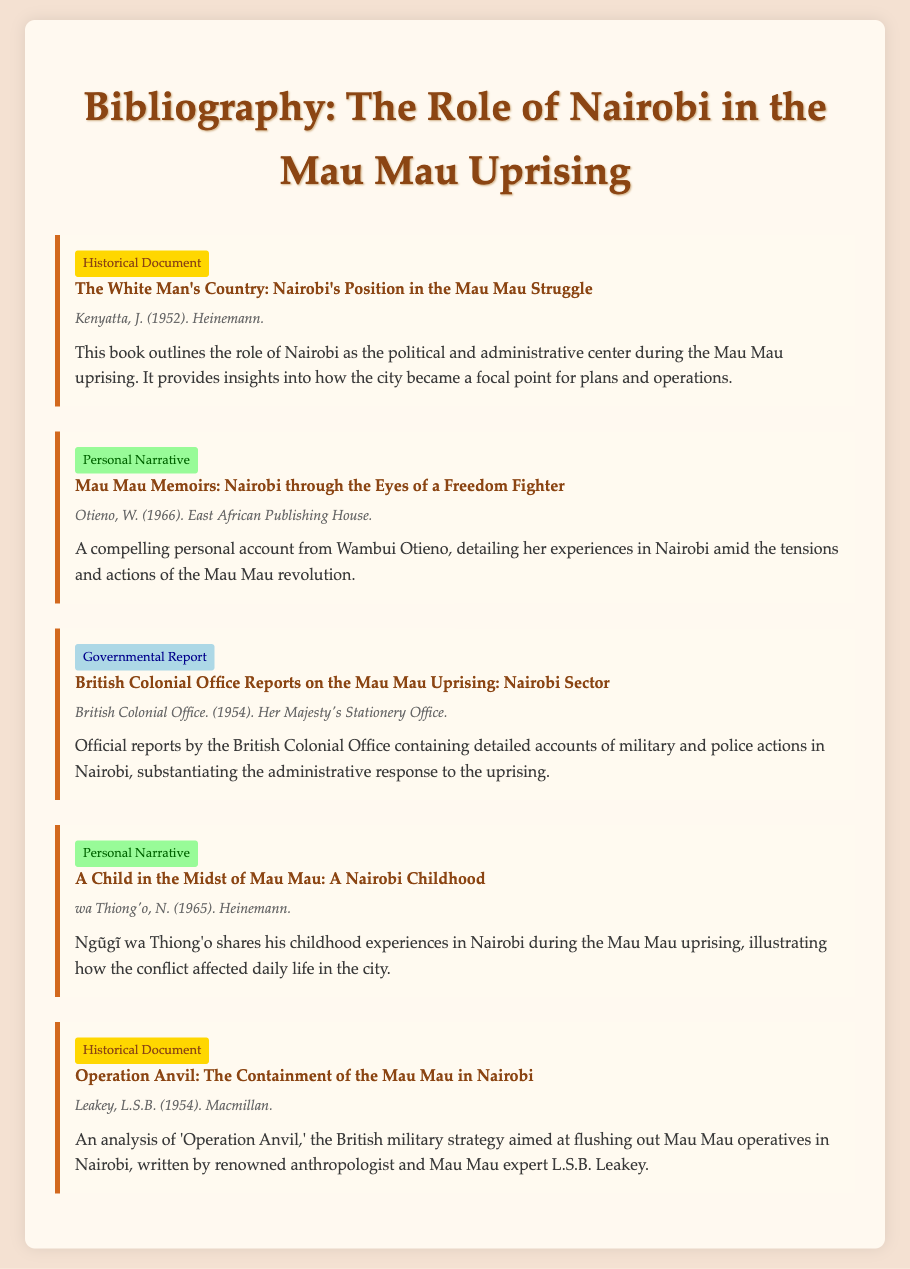What is the title of the first entry? The title of the first entry is listed prominently under each entry in bold type.
Answer: The White Man's Country: Nairobi's Position in the Mau Mau Struggle Who authored "Mau Mau Memoirs"? The authorship of "Mau Mau Memoirs" is indicated right after the title of the entry.
Answer: Otieno, W What is the publication year of the governmental report? The publication year is typically included in the meta information of the entry.
Answer: 1954 Which operation is discussed in the historical document by L.S.B. Leakey? The specific operation is mentioned in the title of the historical document entry.
Answer: Operation Anvil How many personal narratives are included in this bibliography? A count of the entries tagged as personal narratives indicates the number included.
Answer: 2 What color is associated with governmental report entries? The color used for entries categorized as governmental reports is part of the visual styling for the document.
Answer: Light blue Name the publisher of "A Child in the Midst of Mau Mau." The publisher's name is part of the meta information under that particular entry.
Answer: Heinemann What type of document is "The White Man's Country"? The document type is specified at the top of each entry as a label.
Answer: Historical Document 